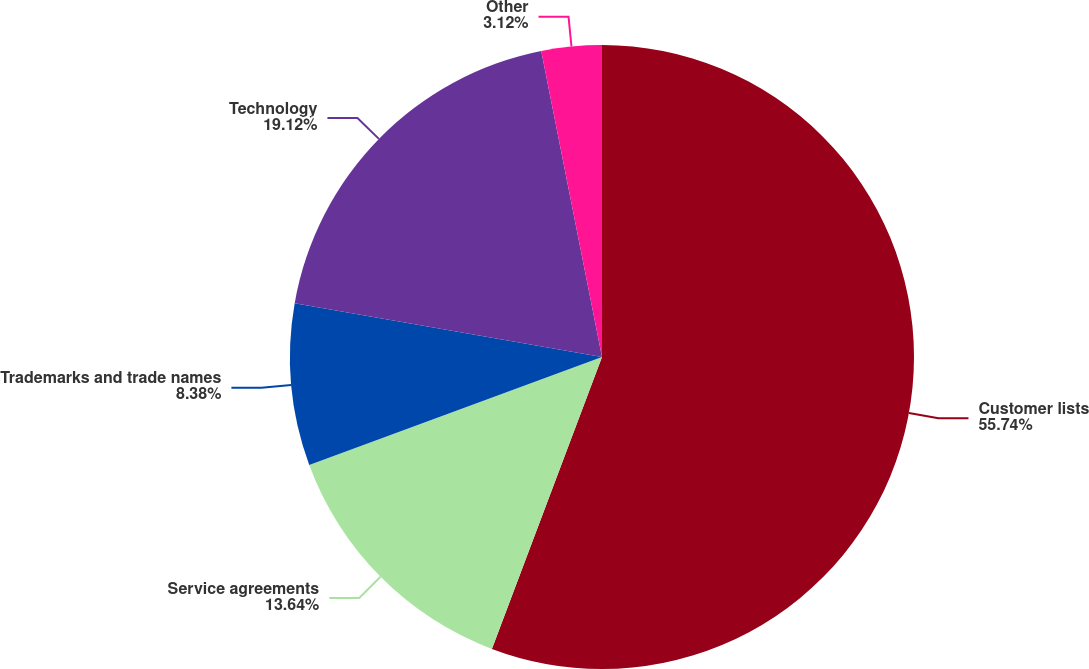Convert chart to OTSL. <chart><loc_0><loc_0><loc_500><loc_500><pie_chart><fcel>Customer lists<fcel>Service agreements<fcel>Trademarks and trade names<fcel>Technology<fcel>Other<nl><fcel>55.74%<fcel>13.64%<fcel>8.38%<fcel>19.12%<fcel>3.12%<nl></chart> 